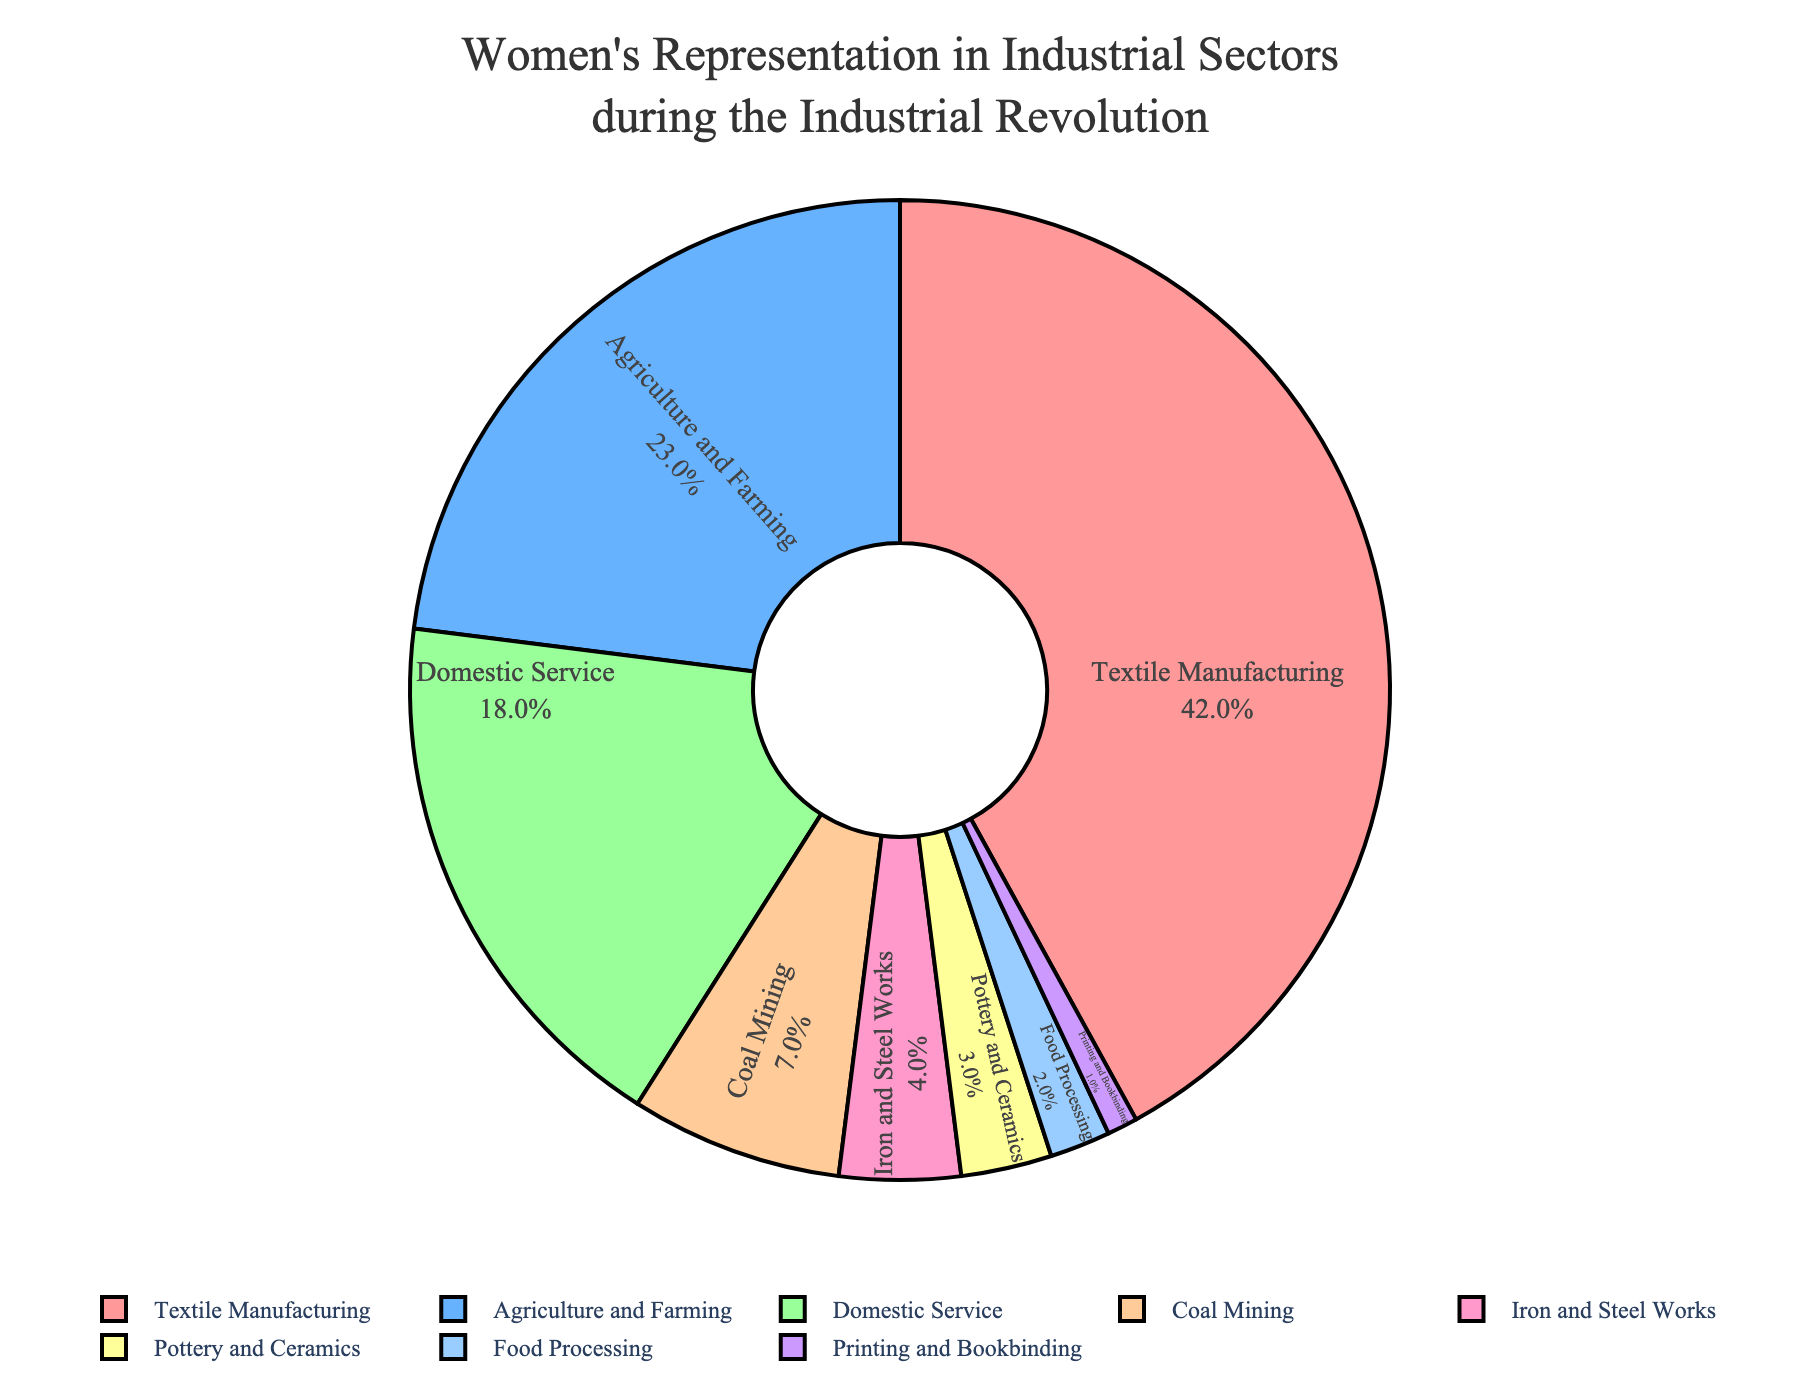Which sector has the highest representation of women? The pie chart shows the highest percentage slice for each sector. The largest segment is labeled "Textile Manufacturing" with 42%.
Answer: Textile Manufacturing Which sectors have a combined representation greater than 50%? Sum the percentages for each sector and find combinations that equal more than 50%. Textile Manufacturing (42%) + Agriculture and Farming (23%) = 65%. This combination exceeds 50%.
Answer: Textile Manufacturing and Agriculture and Farming What is the approximate difference in representation between Coal Mining and Domestic Service? Subtract the percentage of Coal Mining from Domestic Service: 18% (Domestic Service) - 7% (Coal Mining) = 11%.
Answer: 11% How much more representation does the Textile Manufacturing sector have compared to the Agriculture and Farming sector? Subtract the Agriculture and Farming percentage from Textile Manufacturing: 42% - 23% = 19%.
Answer: 19% Which three sectors have the lowest representation of women? Identify and list the sectors with the lowest percentages. The three smallest percentages are from Printing and Bookbinding (1%), Food Processing (2%), and Pottery and Ceramics (3%).
Answer: Printing and Bookbinding, Food Processing, Pottery and Ceramics Are there more women represented in Iron and Steel Works or Coal Mining? Compare the percentages for Iron and Steel Works and Coal Mining. Coal Mining has 7%, while Iron and Steel Works has 4%.
Answer: Coal Mining What percentage of women are involved in sectors other than Textile Manufacturing and Agriculture and Farming? Subtract the percentages for Textile Manufacturing (42%) and Agriculture and Farming (23%) from 100%, then sum the remaining sectors:  100% - (42% + 23%) = 35%.
Answer: 35% Which sector represents a single-digit percentage of women but has more than 5%? Identify the sectors with percentages between 5% and 9%. Coal Mining fits this criterion with 7%.
Answer: Coal Mining If you combine the percentages of women in Domestic Service, Iron and Steel Works, and Pottery and Ceramics, what is the total representation? Add the percentages of these sectors: 18% (Domestic Service) + 4% (Iron and Steel Works) + 3% (Pottery and Ceramics) = 25%.
Answer: 25% How does the representation in Agriculture and Farming compare to that in Domestic Service? Compare the percentages: Agriculture and Farming (23%) is greater than Domestic Service (18%).
Answer: Agriculture and Farming is greater than Domestic Service 